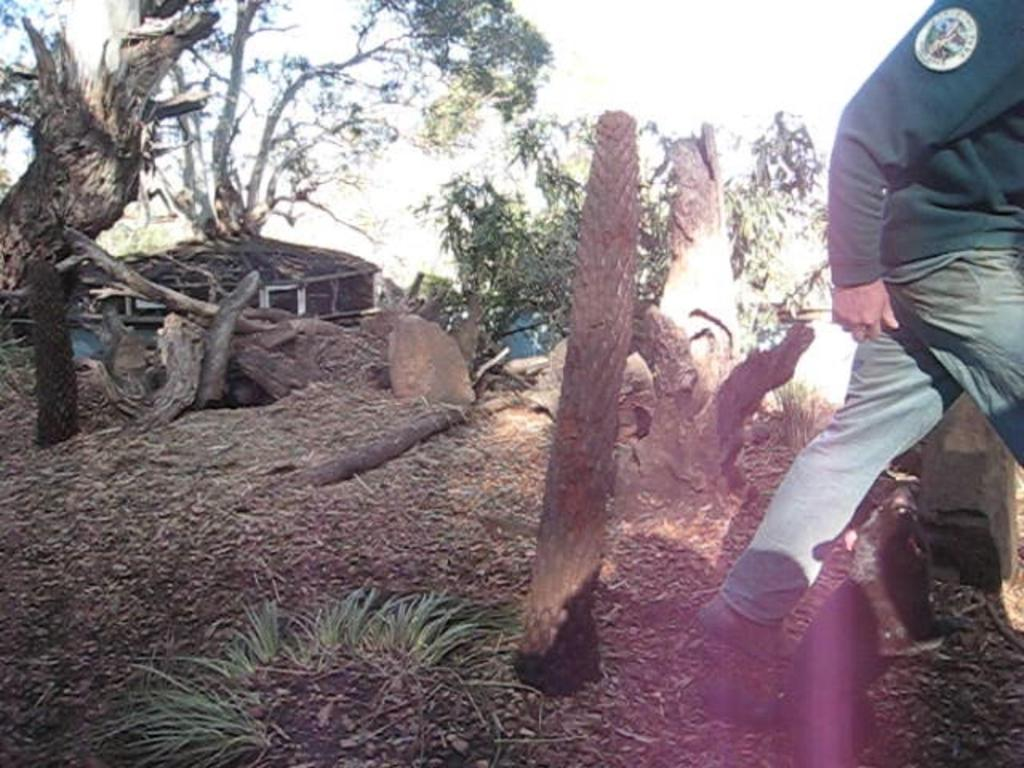What is the main subject of the image? There is a person walking in the image. What can be seen behind the person? There are trees behind the person. What type of material is present on the surface in the image? There are wooden branches on the surface. What is visible in the background of the image? The sky is visible in the background of the image. What is the fifth element in the image? There is no fifth element mentioned in the facts provided, as there are only four elements described: the person walking, trees, wooden branches, and the sky. 